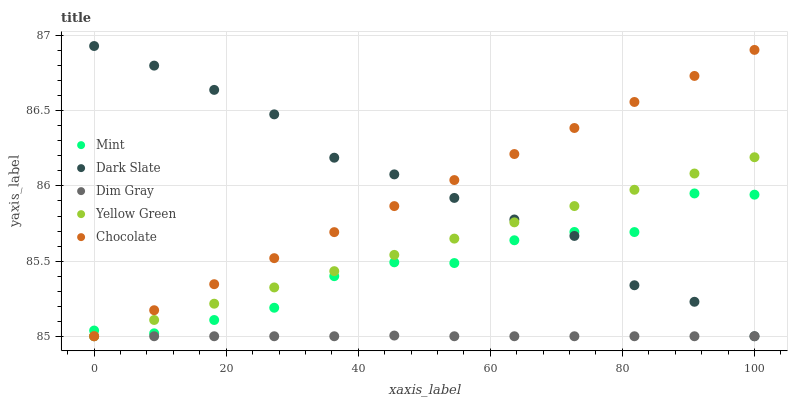Does Dim Gray have the minimum area under the curve?
Answer yes or no. Yes. Does Dark Slate have the maximum area under the curve?
Answer yes or no. Yes. Does Mint have the minimum area under the curve?
Answer yes or no. No. Does Mint have the maximum area under the curve?
Answer yes or no. No. Is Yellow Green the smoothest?
Answer yes or no. Yes. Is Mint the roughest?
Answer yes or no. Yes. Is Dim Gray the smoothest?
Answer yes or no. No. Is Dim Gray the roughest?
Answer yes or no. No. Does Dark Slate have the lowest value?
Answer yes or no. Yes. Does Mint have the lowest value?
Answer yes or no. No. Does Dark Slate have the highest value?
Answer yes or no. Yes. Does Mint have the highest value?
Answer yes or no. No. Is Dim Gray less than Mint?
Answer yes or no. Yes. Is Mint greater than Dim Gray?
Answer yes or no. Yes. Does Dim Gray intersect Yellow Green?
Answer yes or no. Yes. Is Dim Gray less than Yellow Green?
Answer yes or no. No. Is Dim Gray greater than Yellow Green?
Answer yes or no. No. Does Dim Gray intersect Mint?
Answer yes or no. No. 